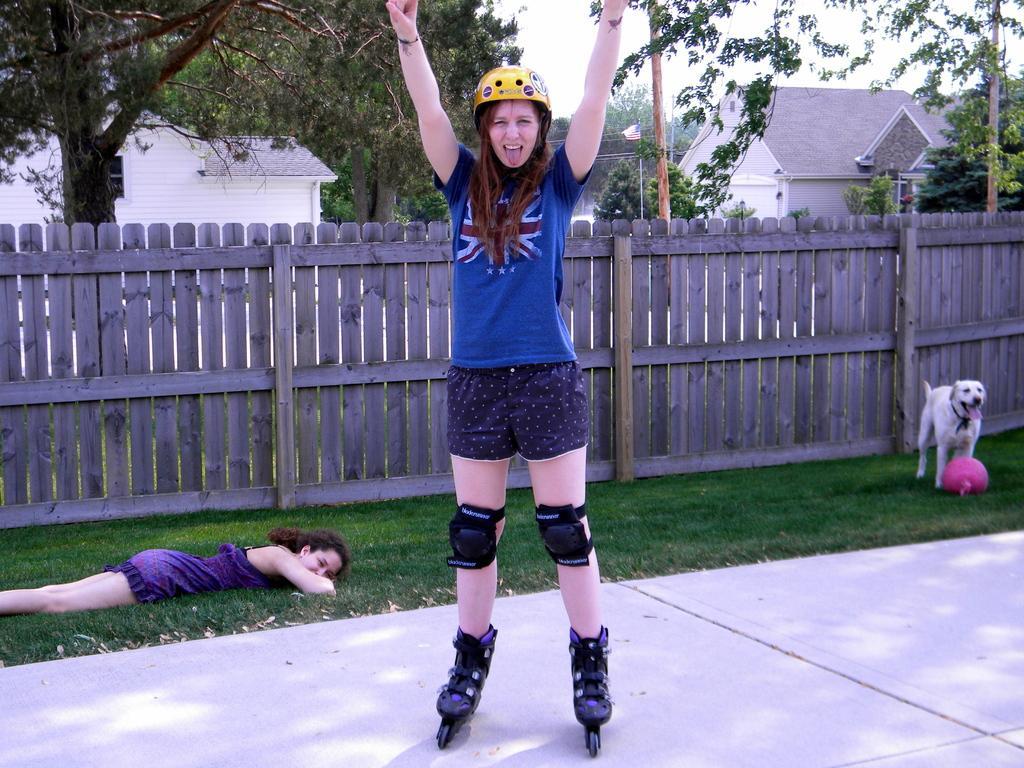Describe this image in one or two sentences. In this image there is a road at the bottom. There is a person sleeping on the left corner. There is a dog and an object on the right corner. There is a person in the foreground. There is a wooden fence, there are buildings and trees in the background. And there is sky at the top. 